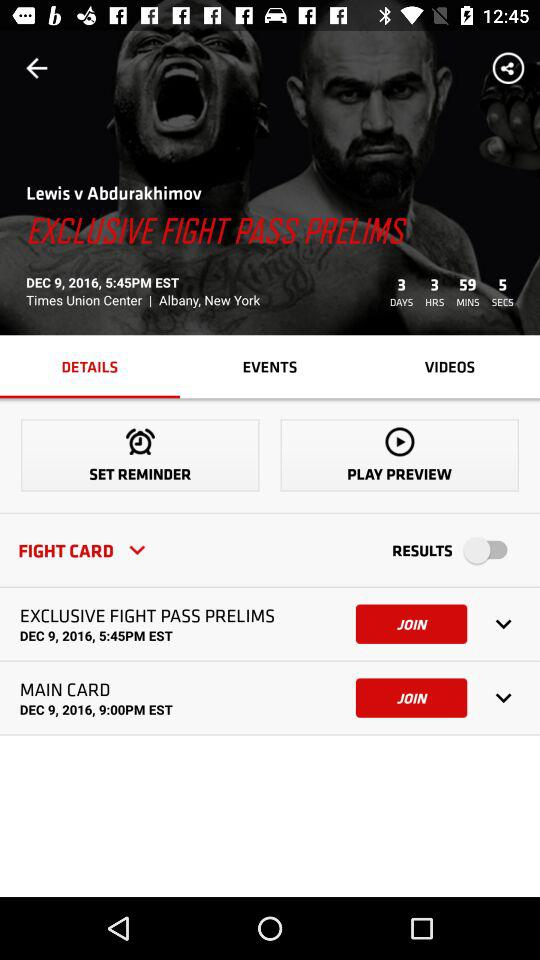How many items are in the fight card?
Answer the question using a single word or phrase. 2 